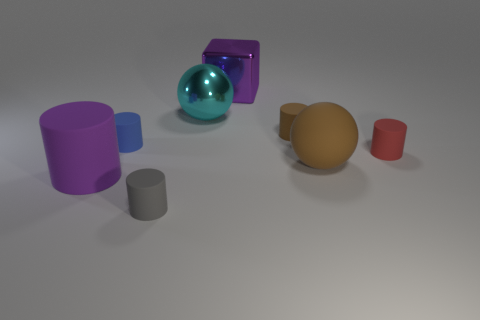There is a cyan metal object that is the same size as the purple matte thing; what is its shape?
Your response must be concise. Sphere. Are there any gray objects in front of the purple rubber object?
Your answer should be very brief. Yes. Are there any big purple matte things that are behind the brown thing behind the large brown matte ball?
Your response must be concise. No. Is the number of objects on the left side of the blue matte object less than the number of tiny objects left of the red rubber cylinder?
Your answer should be very brief. Yes. There is a tiny brown rubber object; what shape is it?
Ensure brevity in your answer.  Cylinder. What material is the sphere to the left of the brown rubber cylinder?
Provide a succinct answer. Metal. What is the size of the cyan metal thing that is in front of the purple thing behind the shiny object that is in front of the purple block?
Offer a very short reply. Large. Are the large sphere behind the large brown object and the large purple object in front of the big cyan thing made of the same material?
Offer a very short reply. No. How many other objects are there of the same color as the rubber sphere?
Keep it short and to the point. 1. How many things are either large balls behind the brown matte cylinder or small cylinders that are to the left of the metal cube?
Your answer should be very brief. 3. 